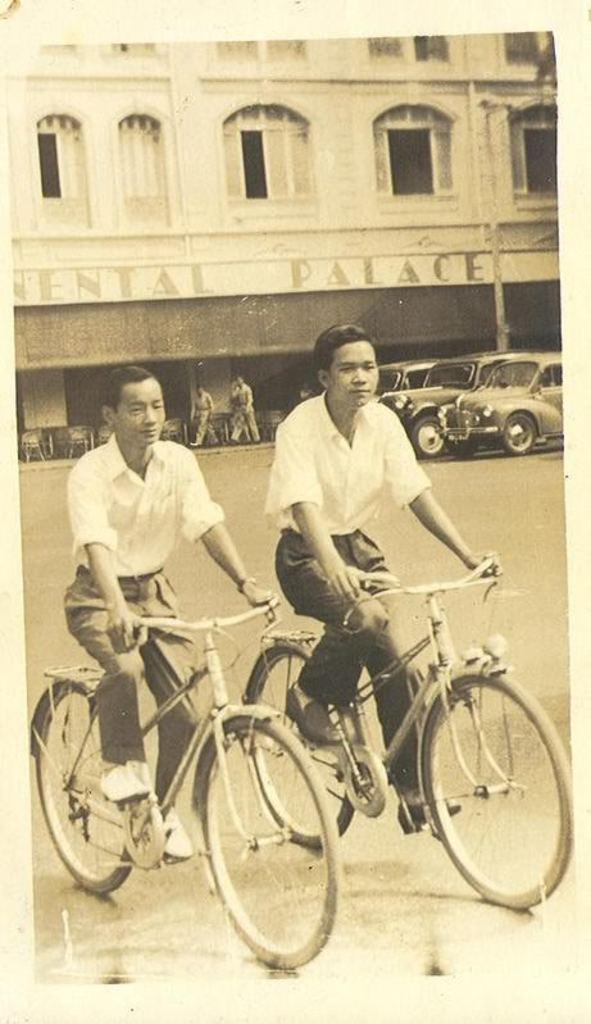Describe this image in one or two sentences. The two persons are riding a bicycle. In the back side we have a remaining people. They are walking. We can see the background there is a building,tree,pole. 